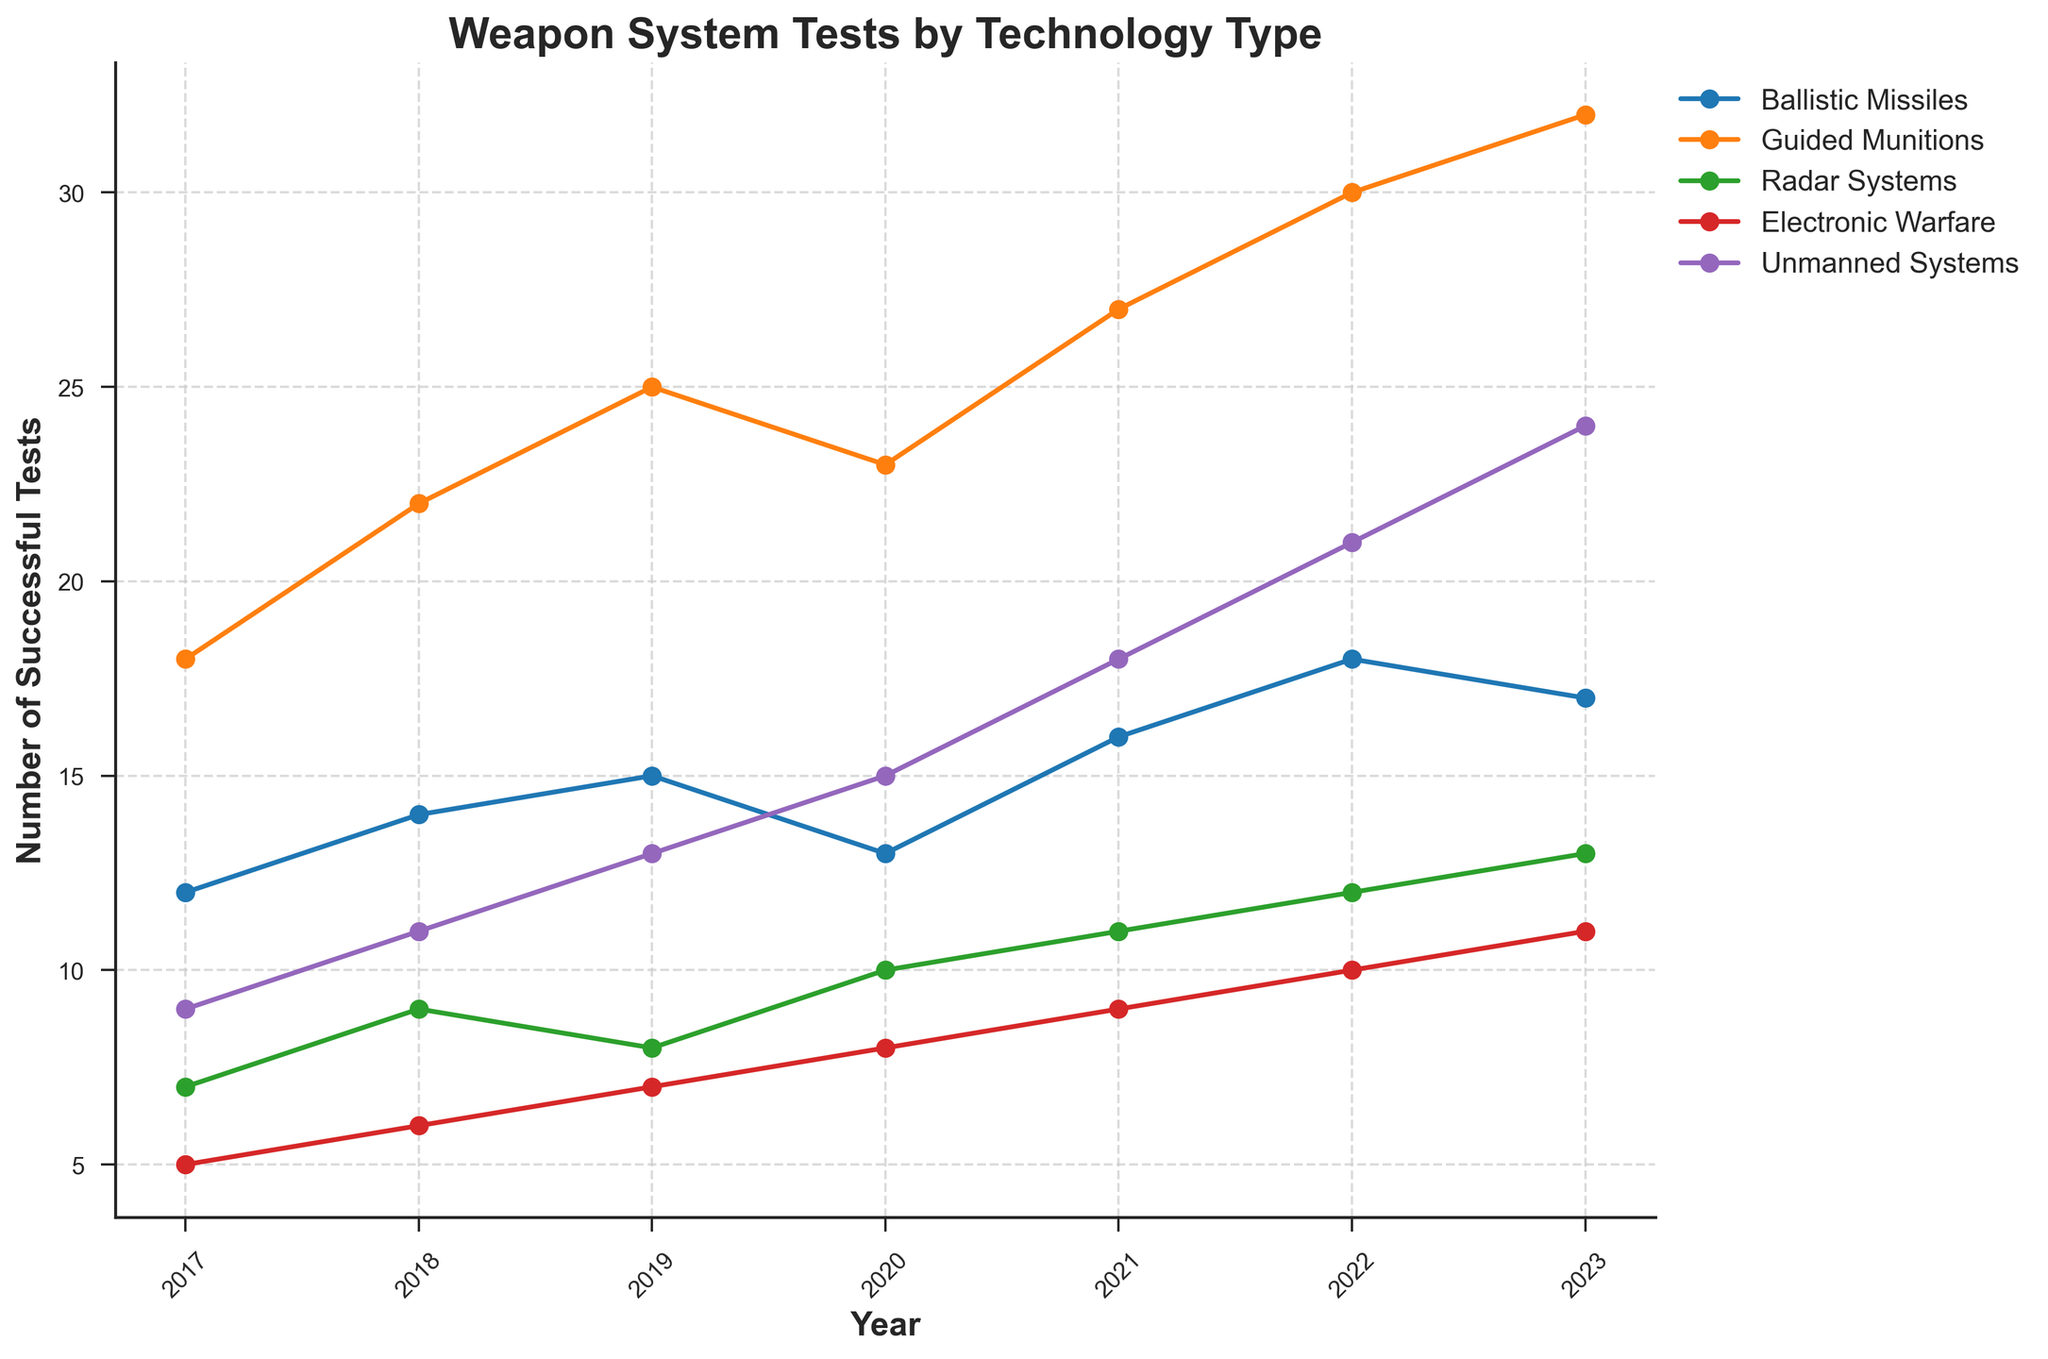What technology type saw the most significant increase from 2017 to 2023? To find the technology type with the most significant increase, we need to calculate the difference for each category between 2017 and 2023. For Ballistic Missiles, the increase is 17 - 12 = 5; for Guided Munitions, it is 32 - 18 = 14; for Radar Systems, it is 13 - 7 = 6; for Electronic Warfare, it is 11 - 5 = 6; and for Unmanned Systems, it is 24 - 9 = 15. The largest increase is in Unmanned Systems.
Answer: Unmanned Systems Which year had the highest number of successful tests for Electronic Warfare? By examining the line for Electronic Warfare, we see the number of successful tests per year. Check the values for each year and identify the highest one. In 2019, 2020, 2021, 2022, and 2023, the values are 7, 8, 9, 10, and 11, respectively. The highest value is 11 in 2023.
Answer: 2023 Among the different technology types, which one had the least number of tests conducted in 2020? In the year 2020, the values for the five categories are: Ballistic Missiles: 13, Guided Munitions: 23, Radar Systems: 10, Electronic Warfare: 8, and Unmanned Systems: 15. The smallest value is 8, which corresponds to Electronic Warfare.
Answer: Electronic Warfare How many more successful tests were conducted for Unmanned Systems in 2023 compared to 2017? To determine the increase, subtract the value for 2017 from that of 2023: 24 (2023) - 9 (2017) = 15.
Answer: 15 What was the average number of successful tests conducted for Radar Systems from 2017 to 2023? To find the average, sum the number of tests for each year and divide by the number of years. The values are 7, 9, 8, 10, 11, 12, and 13. The sum is 70; divide by 7 (the number of years): 70 / 7 = 10.
Answer: 10 Did Radar Systems see any years with a decrease in successful tests? If so, which years? Compare the values year by year to identify any decrease. Between 2017–2018: 7 to 9 (increase), 2018–2019: 9 to 8 (decrease), 2019–2020: 8 to 10 (increase), followed by consistent increases. Thus, there was a decrease from 2018 to 2019.
Answer: 2018-2019 How many total successful tests were conducted in 2021 for all technology types combined? Add the totals for each category for the year 2021. Ballistic Missiles: 16, Guided Munitions: 27, Radar Systems: 11, Electronic Warfare: 9, and Unmanned Systems: 18. Sum = 16 + 27 + 11 + 9 + 18 = 81.
Answer: 81 Which technology type had the most consistent (least varying) number of successful tests from 2017 to 2023? By visually assessing the line chart slopes and overall changes, Guided Munitions show a gradual and consistent increase without significant drops or spikes, indicating the most consistent performance.
Answer: Guided Munitions In what year did Guided Munitions surpass the 30 successful test mark? Assess the Guided Munitions line to see where it crosses the 30 test mark. The line surpasses 30 successful tests in the year 2022.
Answer: 2022 